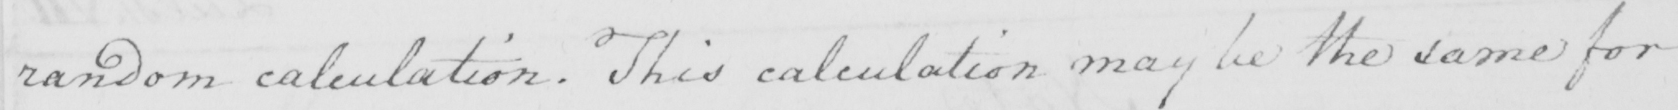Transcribe the text shown in this historical manuscript line. random calculation . This calculation may be the same for 